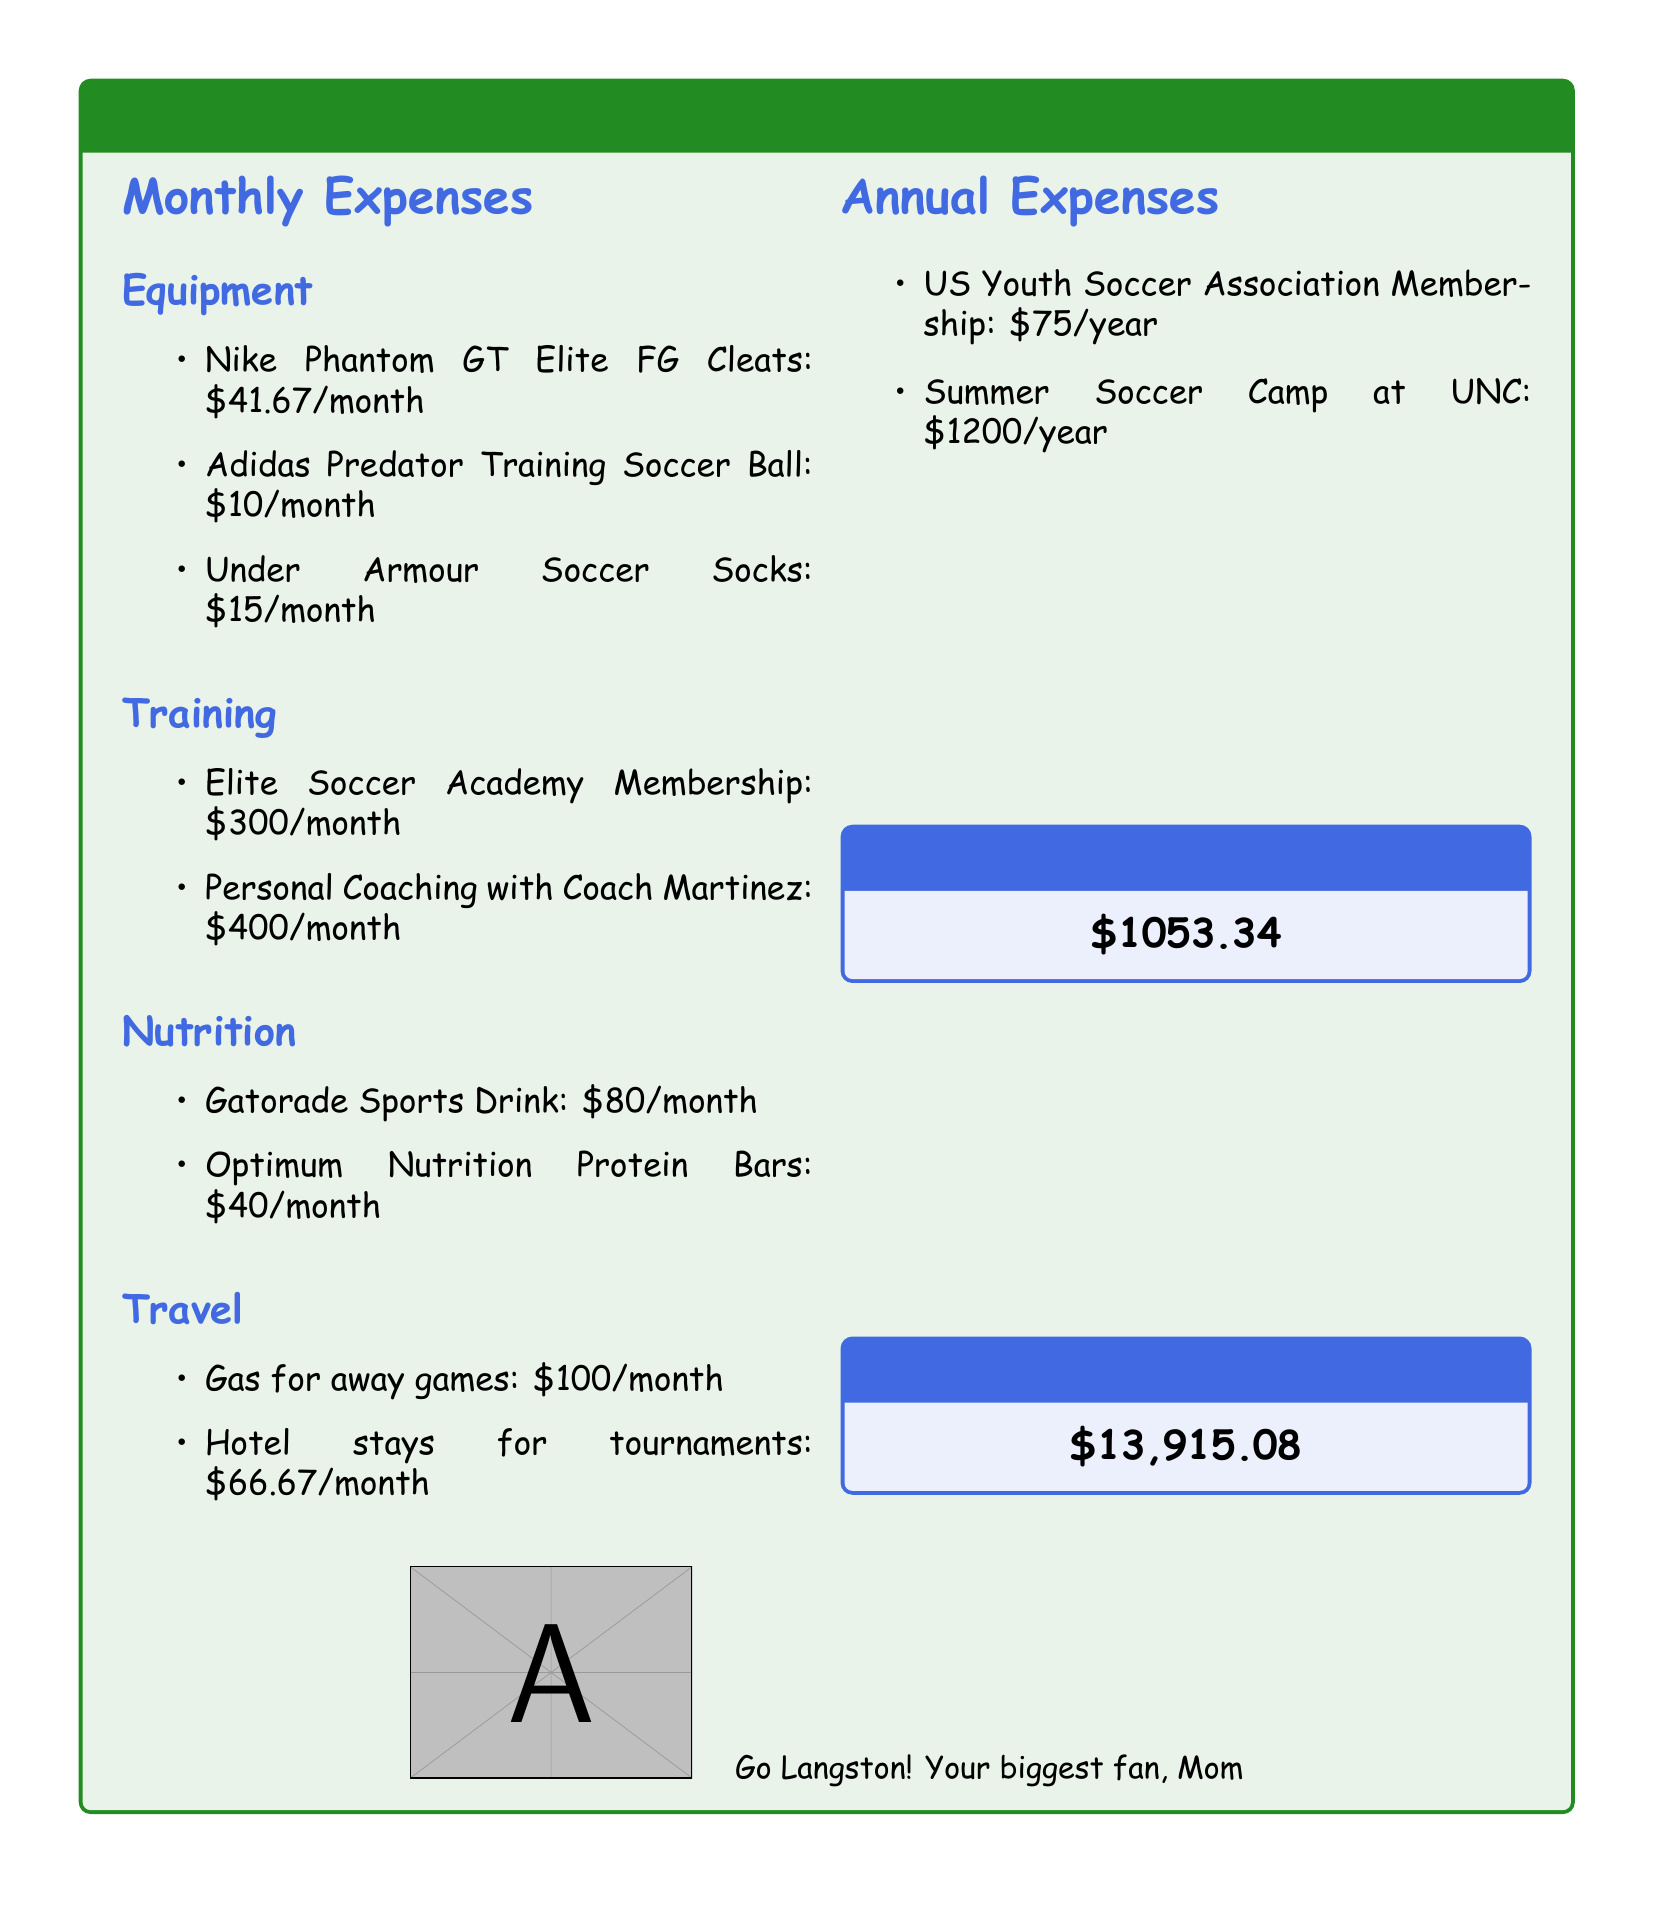What is the total monthly expense? The total monthly expense is provided at the end of the budget summary section.
Answer: $1053.34 What is the cost of personal coaching with Coach Martinez? The cost is found in the Training section of the document.
Answer: $400/month How much is spent on gas for away games? This amount is listed under the Travel expenses.
Answer: $100/month What type of ball is included in the equipment expenses? The specific item mentioned is in the Equipment section.
Answer: Adidas Predator Training Soccer Ball What is the annual cost for the Summer Soccer Camp at UNC? This annual expense is listed in the Annual Expenses section of the document.
Answer: $1200/year What are the monthly expenses for nutrition? This can be calculated by adding the monthly nutrition items listed in the document.
Answer: $120/month What is the total annual expense? The total annual expenses are given at the end of the budget document.
Answer: $13,915.08 What membership fee is required for the US Youth Soccer Association? This specific annual fee is found in the Annual Expenses section.
Answer: $75/year What color is used for the budget title box? The color of the title box is described at the beginning of the document.
Answer: soccergreen 